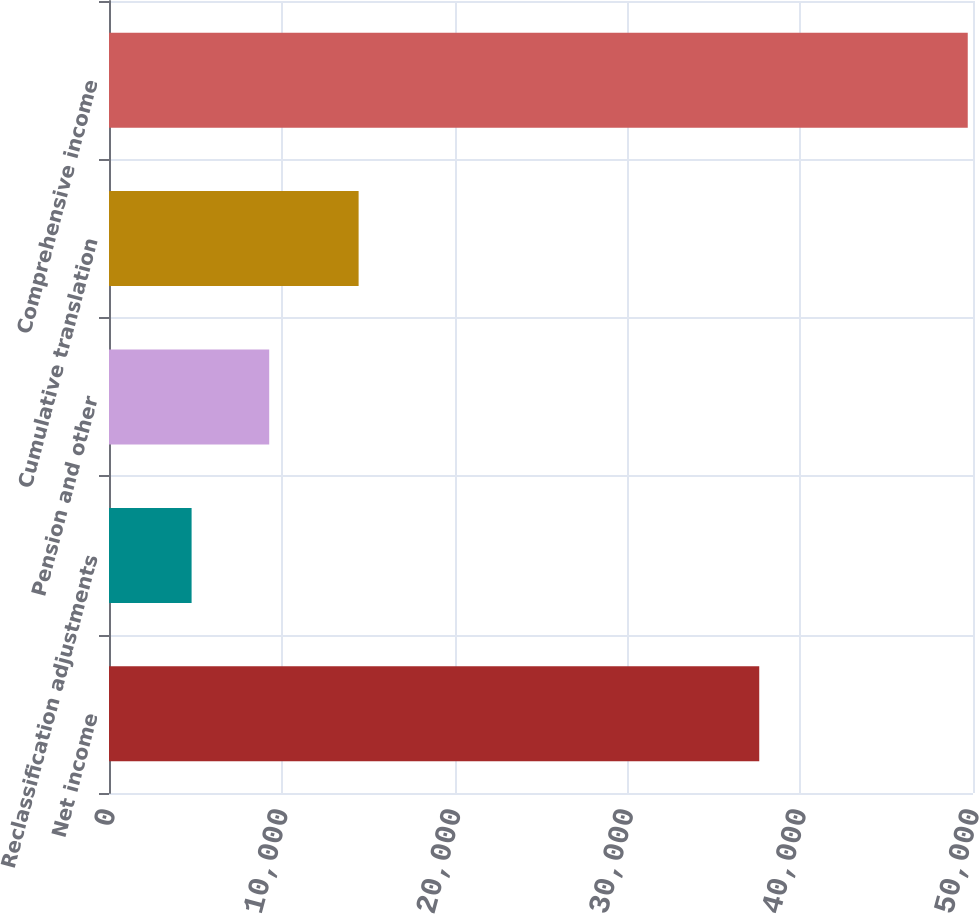<chart> <loc_0><loc_0><loc_500><loc_500><bar_chart><fcel>Net income<fcel>Reclassification adjustments<fcel>Pension and other<fcel>Cumulative translation<fcel>Comprehensive income<nl><fcel>37630<fcel>4780<fcel>9271.6<fcel>14445<fcel>49696<nl></chart> 